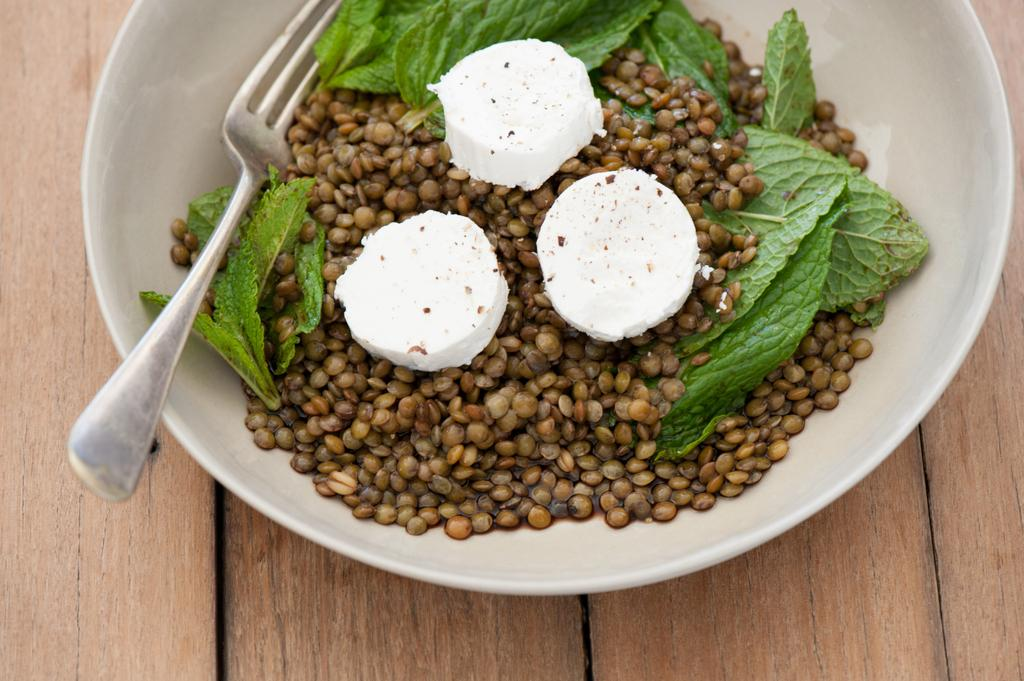What piece of furniture is present in the image? There is a table in the image. What is placed on the table? There is a bowl on the table. What utensil can be seen in the bowl? There is a fork in the bowl. What type of food is in the bowl? There are beans seeds in the bowl. What is the price of the lettuce in the image? There is no lettuce present in the image, so it is not possible to determine its price. 